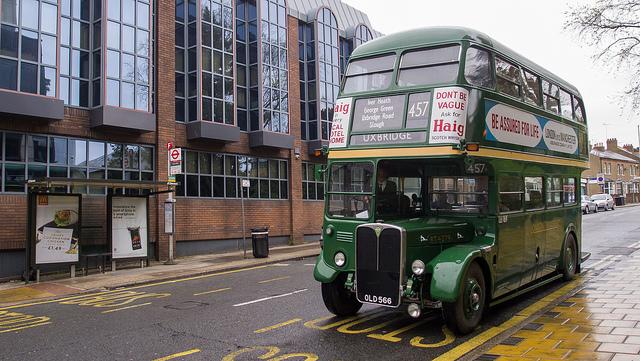How many buses are there?
Quick response, please. 1. How is the street?
Write a very short answer. Wet. What color is the double-decker bus?
Answer briefly. Green. On what side of the road is this bus driving?
Answer briefly. Left. 